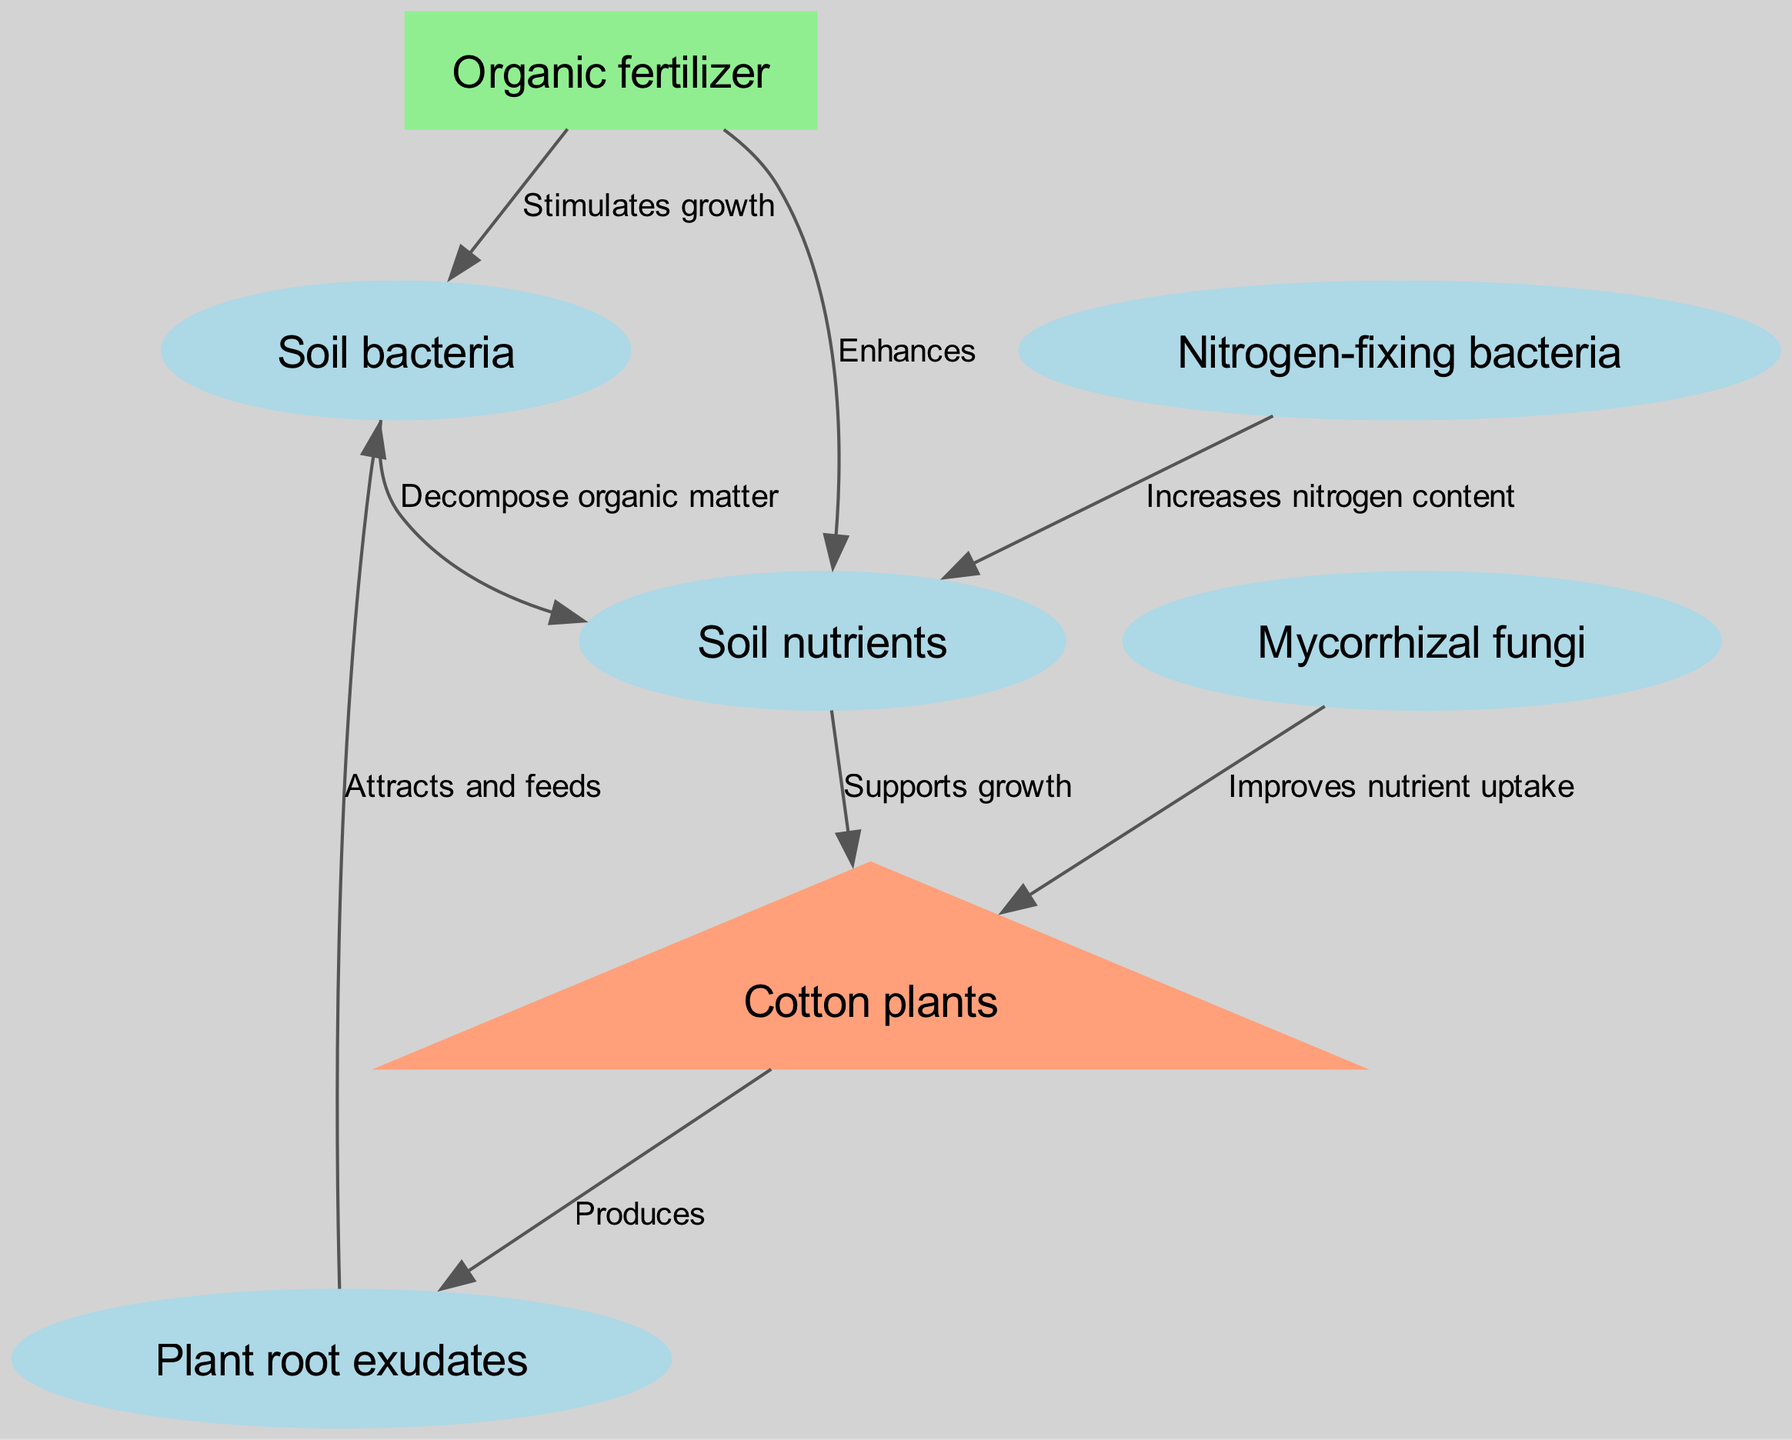What is the number of nodes in the diagram? The diagram consists of six nodes: Organic fertilizer, Cotton plants, Soil bacteria, Mycorrhizal fungi, Nitrogen-fixing bacteria, and Soil nutrients. Counting each of these nodes provides a total of six.
Answer: 6 Which node produces plant root exudates? According to the diagram, Cotton plants produce Plant root exudates, as indicated by the arrow going from Cotton plants pointing towards Plant root exudates.
Answer: Cotton plants What relationship does Organic fertilizer have with Soil bacteria? The diagram shows a direct relationship: Organic fertilizer stimulates the growth of Soil bacteria, as indicated by the arrow labeled "Stimulates growth."
Answer: Stimulates growth How do Soil bacteria influence Soil nutrients? The connection in the diagram states that Soil bacteria decompose organic matter, which directly relates to the availability of Soil nutrients, as highlighted by the edge labeled "Decompose organic matter."
Answer: Decompose organic matter What is the role of Mycorrhizal fungi in relation to Cotton plants? The diagram illustrates that Mycorrhizal fungi improve the nutrient uptake for Cotton plants. This is shown by the arrow connecting Mycorrhizal fungi to Cotton plants labeled "Improves nutrient uptake."
Answer: Improves nutrient uptake What influences the nitrogen content in Soil nutrients? Nitrogen-fixing bacteria are responsible for increasing the nitrogen content in Soil nutrients, as indicated by the edge connecting Nitrogen-fixing bacteria to Soil nutrients labeled "Increases nitrogen content."
Answer: Increases nitrogen content Which nodes are directly connected to Soil nutrients? The nodes directly connected to Soil nutrients include Soil bacteria and Nitrogen-fixing bacteria, which both influence it. Additionally, Soil nutrients support Cotton plants, connecting this node to another.
Answer: Soil bacteria, Nitrogen-fixing bacteria, Cotton plants What do Plant root exudates do for Soil bacteria? The diagram indicates that Plant root exudates attract and feed Soil bacteria, as represented by the directed edge labeled "Attracts and feeds."
Answer: Attracts and feeds What is the final growth-supporting factor for Cotton plants according to the diagram? The final growth-supporting factor for Cotton plants is Soil nutrients, which support their growth as indicated by the edge labeled "Supports growth."
Answer: Supports growth 